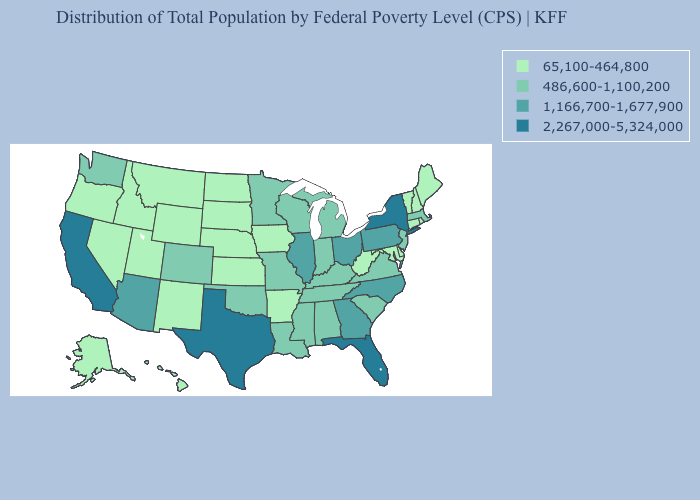Is the legend a continuous bar?
Answer briefly. No. Does Virginia have the same value as Arizona?
Concise answer only. No. What is the value of Montana?
Short answer required. 65,100-464,800. How many symbols are there in the legend?
Short answer required. 4. Does Hawaii have the highest value in the West?
Short answer required. No. What is the value of Tennessee?
Be succinct. 486,600-1,100,200. Does Montana have a lower value than Nevada?
Quick response, please. No. Name the states that have a value in the range 65,100-464,800?
Write a very short answer. Alaska, Arkansas, Connecticut, Delaware, Hawaii, Idaho, Iowa, Kansas, Maine, Maryland, Montana, Nebraska, Nevada, New Hampshire, New Mexico, North Dakota, Oregon, Rhode Island, South Dakota, Utah, Vermont, West Virginia, Wyoming. Among the states that border North Dakota , which have the lowest value?
Be succinct. Montana, South Dakota. Which states have the lowest value in the MidWest?
Write a very short answer. Iowa, Kansas, Nebraska, North Dakota, South Dakota. What is the value of South Carolina?
Be succinct. 486,600-1,100,200. What is the value of South Dakota?
Keep it brief. 65,100-464,800. Does Maryland have the highest value in the USA?
Concise answer only. No. What is the highest value in the West ?
Keep it brief. 2,267,000-5,324,000. 